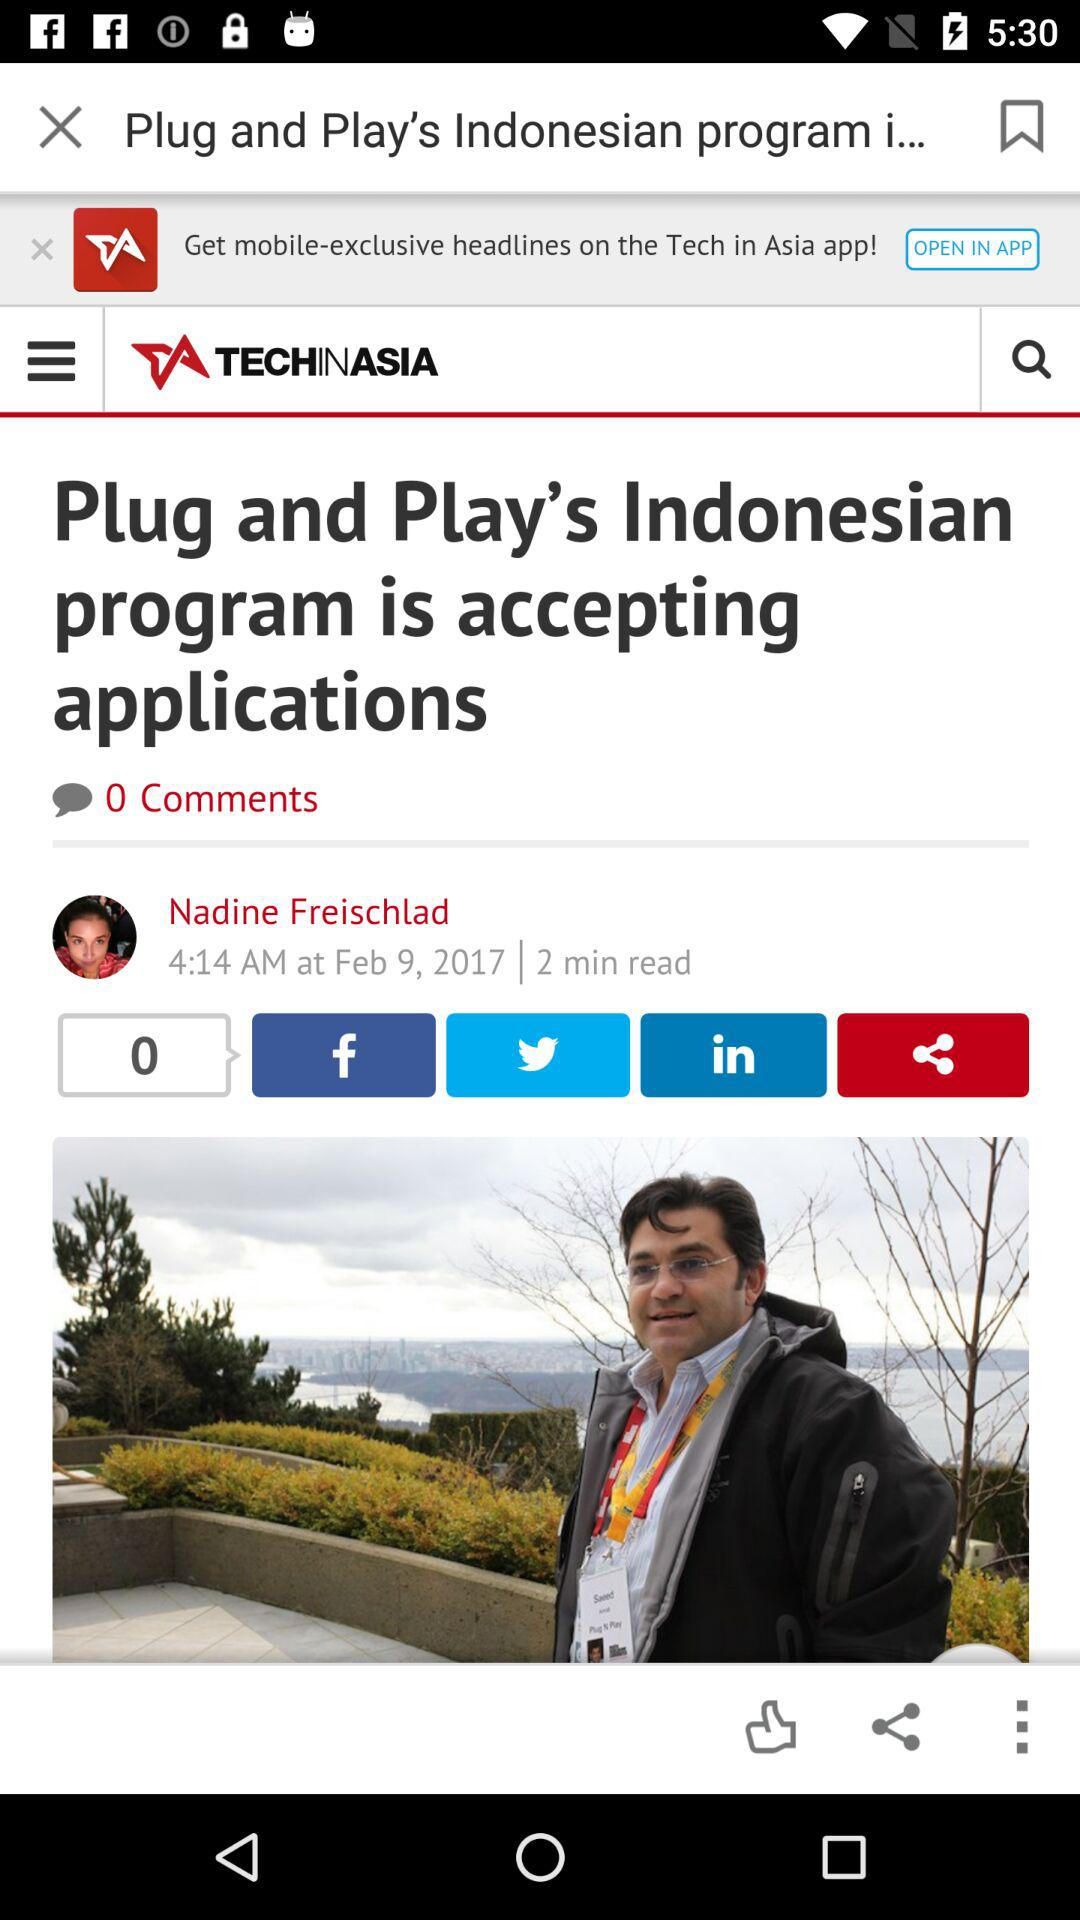When did Nadine Freischlad posted? Nadine Freischlad posted on February 9, 2017. 